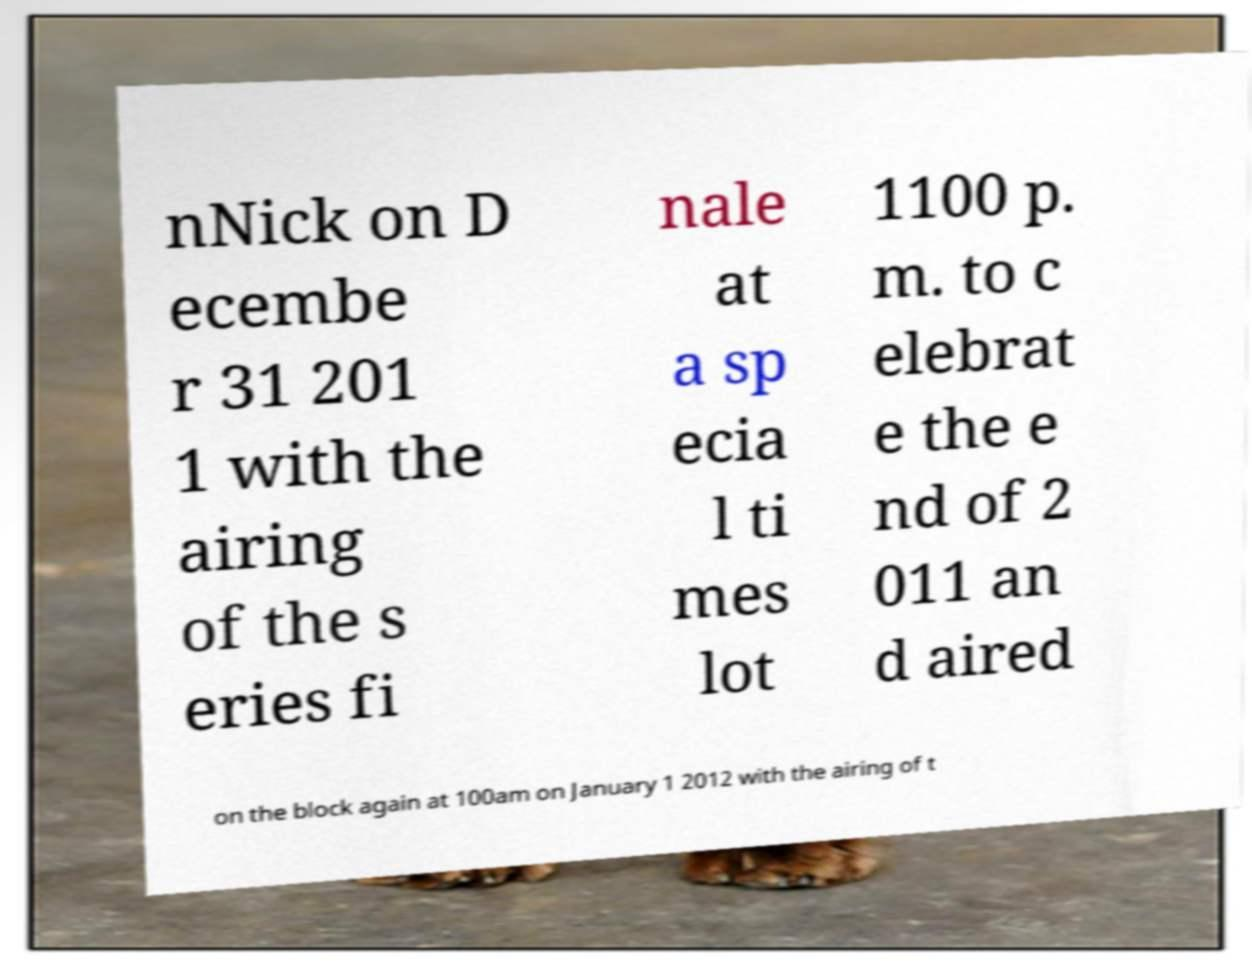What messages or text are displayed in this image? I need them in a readable, typed format. nNick on D ecembe r 31 201 1 with the airing of the s eries fi nale at a sp ecia l ti mes lot 1100 p. m. to c elebrat e the e nd of 2 011 an d aired on the block again at 100am on January 1 2012 with the airing of t 